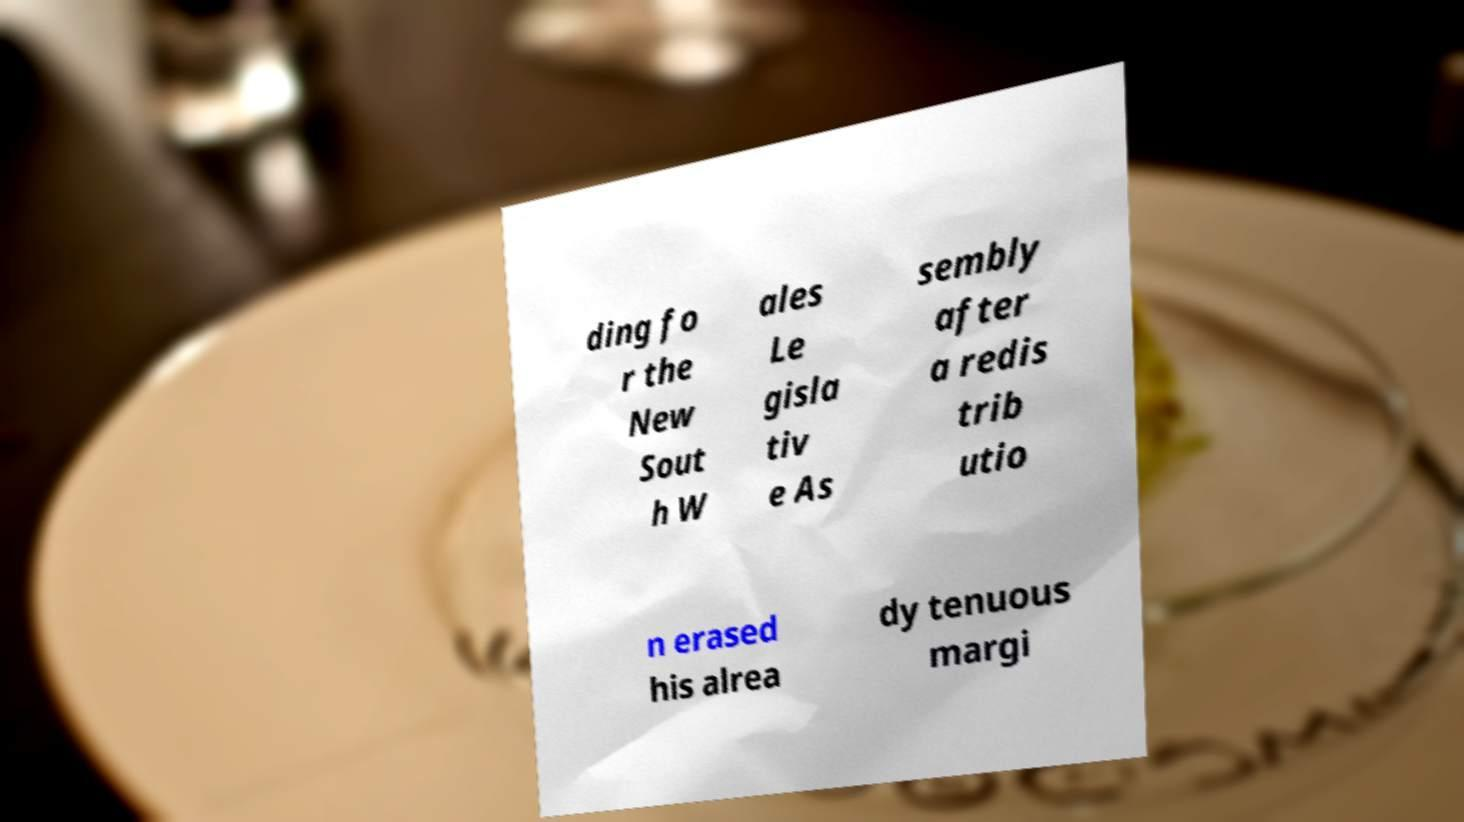I need the written content from this picture converted into text. Can you do that? ding fo r the New Sout h W ales Le gisla tiv e As sembly after a redis trib utio n erased his alrea dy tenuous margi 